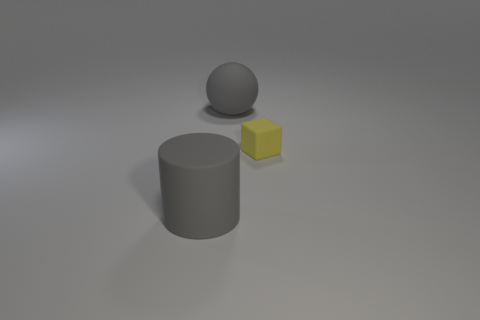Is there any other thing that is the same size as the matte cube?
Provide a short and direct response. No. There is a gray rubber sphere; is it the same size as the gray rubber object that is to the left of the gray rubber ball?
Offer a terse response. Yes. What is the color of the matte thing that is to the left of the tiny block and behind the large gray cylinder?
Offer a terse response. Gray. What number of other things are there of the same shape as the tiny matte thing?
Provide a short and direct response. 0. There is a big rubber thing that is in front of the large gray ball; is its color the same as the large rubber thing that is behind the gray cylinder?
Offer a very short reply. Yes. There is a thing in front of the yellow thing; does it have the same size as the gray matte object that is right of the rubber cylinder?
Offer a terse response. Yes. What number of objects have the same color as the big sphere?
Offer a very short reply. 1. What size is the yellow cube that is made of the same material as the gray cylinder?
Your answer should be very brief. Small. How many yellow things are cylinders or small metallic cylinders?
Your response must be concise. 0. There is a tiny yellow rubber object in front of the gray rubber sphere; how many big gray rubber objects are in front of it?
Provide a succinct answer. 1. 